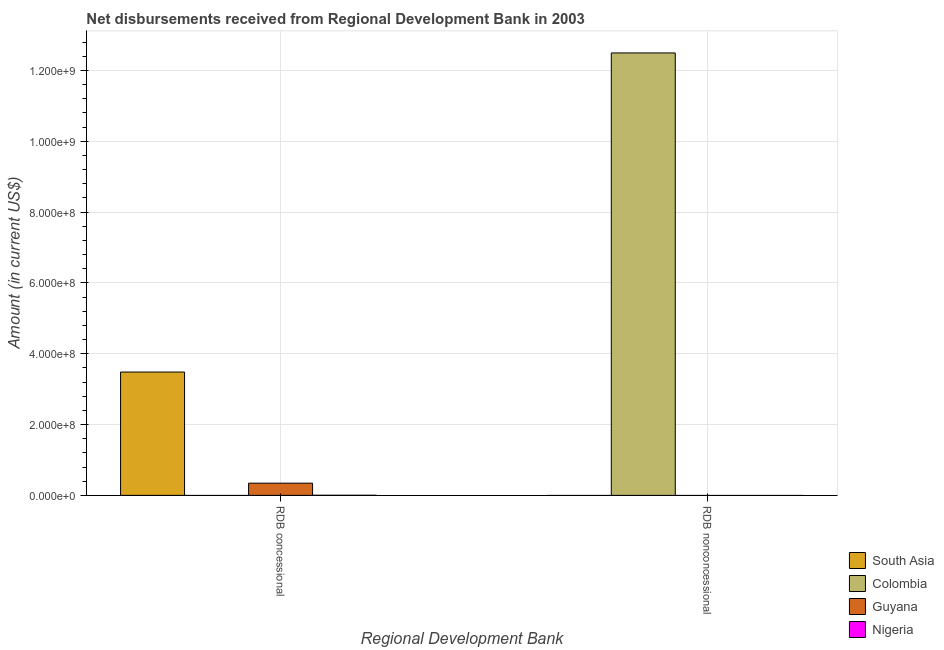Are the number of bars per tick equal to the number of legend labels?
Provide a succinct answer. No. How many bars are there on the 2nd tick from the left?
Your response must be concise. 1. What is the label of the 1st group of bars from the left?
Offer a terse response. RDB concessional. What is the net concessional disbursements from rdb in Guyana?
Ensure brevity in your answer.  3.45e+07. Across all countries, what is the maximum net non concessional disbursements from rdb?
Provide a succinct answer. 1.25e+09. In which country was the net non concessional disbursements from rdb maximum?
Your answer should be compact. Colombia. What is the total net concessional disbursements from rdb in the graph?
Offer a terse response. 3.83e+08. What is the difference between the net concessional disbursements from rdb in Guyana and that in Nigeria?
Provide a succinct answer. 3.41e+07. What is the difference between the net concessional disbursements from rdb in South Asia and the net non concessional disbursements from rdb in Nigeria?
Your answer should be very brief. 3.48e+08. What is the average net concessional disbursements from rdb per country?
Your answer should be very brief. 9.58e+07. In how many countries, is the net concessional disbursements from rdb greater than 800000000 US$?
Your response must be concise. 0. How many bars are there?
Your answer should be very brief. 4. Are all the bars in the graph horizontal?
Provide a succinct answer. No. What is the difference between two consecutive major ticks on the Y-axis?
Your answer should be compact. 2.00e+08. Are the values on the major ticks of Y-axis written in scientific E-notation?
Give a very brief answer. Yes. Does the graph contain grids?
Ensure brevity in your answer.  Yes. How are the legend labels stacked?
Give a very brief answer. Vertical. What is the title of the graph?
Offer a terse response. Net disbursements received from Regional Development Bank in 2003. Does "High income: OECD" appear as one of the legend labels in the graph?
Your response must be concise. No. What is the label or title of the X-axis?
Offer a terse response. Regional Development Bank. What is the Amount (in current US$) of South Asia in RDB concessional?
Provide a short and direct response. 3.48e+08. What is the Amount (in current US$) of Guyana in RDB concessional?
Provide a short and direct response. 3.45e+07. What is the Amount (in current US$) of Nigeria in RDB concessional?
Your response must be concise. 3.73e+05. What is the Amount (in current US$) in Colombia in RDB nonconcessional?
Make the answer very short. 1.25e+09. What is the Amount (in current US$) in Guyana in RDB nonconcessional?
Your answer should be very brief. 0. What is the Amount (in current US$) of Nigeria in RDB nonconcessional?
Offer a very short reply. 0. Across all Regional Development Bank, what is the maximum Amount (in current US$) in South Asia?
Ensure brevity in your answer.  3.48e+08. Across all Regional Development Bank, what is the maximum Amount (in current US$) in Colombia?
Make the answer very short. 1.25e+09. Across all Regional Development Bank, what is the maximum Amount (in current US$) of Guyana?
Make the answer very short. 3.45e+07. Across all Regional Development Bank, what is the maximum Amount (in current US$) in Nigeria?
Make the answer very short. 3.73e+05. Across all Regional Development Bank, what is the minimum Amount (in current US$) in South Asia?
Your answer should be very brief. 0. Across all Regional Development Bank, what is the minimum Amount (in current US$) in Colombia?
Offer a terse response. 0. Across all Regional Development Bank, what is the minimum Amount (in current US$) of Nigeria?
Make the answer very short. 0. What is the total Amount (in current US$) of South Asia in the graph?
Provide a short and direct response. 3.48e+08. What is the total Amount (in current US$) in Colombia in the graph?
Provide a short and direct response. 1.25e+09. What is the total Amount (in current US$) of Guyana in the graph?
Offer a terse response. 3.45e+07. What is the total Amount (in current US$) in Nigeria in the graph?
Keep it short and to the point. 3.73e+05. What is the difference between the Amount (in current US$) in South Asia in RDB concessional and the Amount (in current US$) in Colombia in RDB nonconcessional?
Make the answer very short. -9.01e+08. What is the average Amount (in current US$) of South Asia per Regional Development Bank?
Ensure brevity in your answer.  1.74e+08. What is the average Amount (in current US$) in Colombia per Regional Development Bank?
Your response must be concise. 6.25e+08. What is the average Amount (in current US$) of Guyana per Regional Development Bank?
Offer a terse response. 1.73e+07. What is the average Amount (in current US$) of Nigeria per Regional Development Bank?
Make the answer very short. 1.86e+05. What is the difference between the Amount (in current US$) of South Asia and Amount (in current US$) of Guyana in RDB concessional?
Offer a very short reply. 3.14e+08. What is the difference between the Amount (in current US$) of South Asia and Amount (in current US$) of Nigeria in RDB concessional?
Your answer should be very brief. 3.48e+08. What is the difference between the Amount (in current US$) in Guyana and Amount (in current US$) in Nigeria in RDB concessional?
Give a very brief answer. 3.41e+07. What is the difference between the highest and the lowest Amount (in current US$) of South Asia?
Offer a terse response. 3.48e+08. What is the difference between the highest and the lowest Amount (in current US$) in Colombia?
Provide a short and direct response. 1.25e+09. What is the difference between the highest and the lowest Amount (in current US$) in Guyana?
Give a very brief answer. 3.45e+07. What is the difference between the highest and the lowest Amount (in current US$) of Nigeria?
Your answer should be very brief. 3.73e+05. 